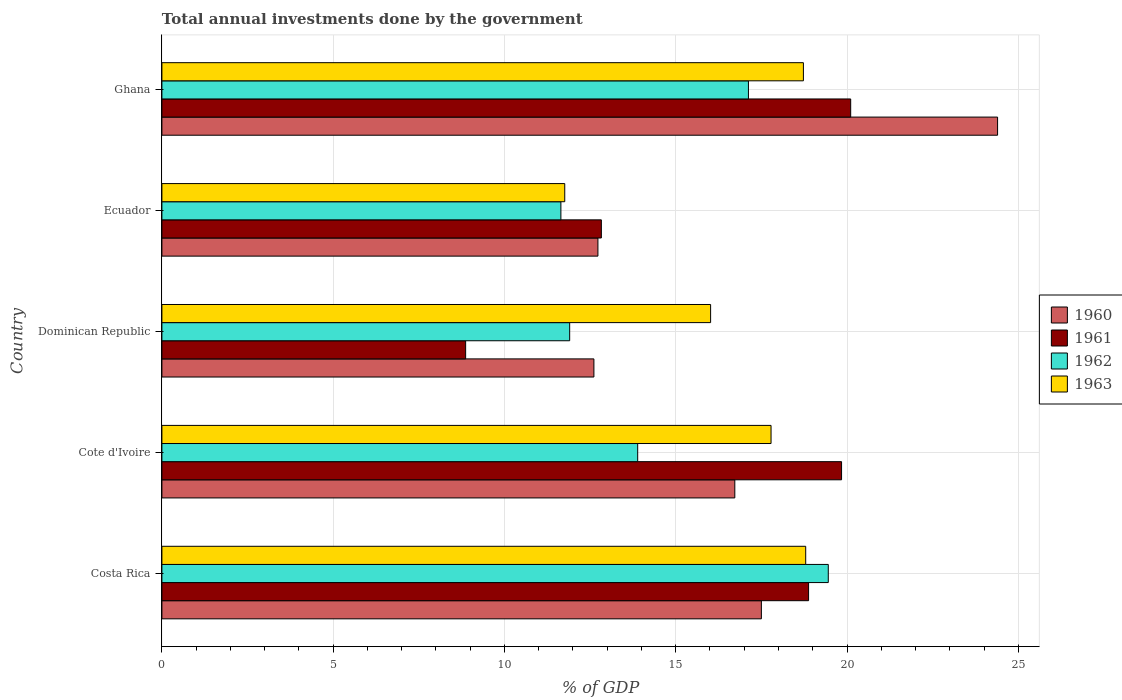How many different coloured bars are there?
Your answer should be compact. 4. How many groups of bars are there?
Your answer should be very brief. 5. Are the number of bars per tick equal to the number of legend labels?
Your answer should be compact. Yes. Are the number of bars on each tick of the Y-axis equal?
Provide a short and direct response. Yes. How many bars are there on the 4th tick from the top?
Ensure brevity in your answer.  4. What is the label of the 4th group of bars from the top?
Your answer should be compact. Cote d'Ivoire. What is the total annual investments done by the government in 1960 in Cote d'Ivoire?
Make the answer very short. 16.72. Across all countries, what is the maximum total annual investments done by the government in 1963?
Ensure brevity in your answer.  18.79. Across all countries, what is the minimum total annual investments done by the government in 1960?
Offer a very short reply. 12.61. In which country was the total annual investments done by the government in 1961 maximum?
Make the answer very short. Ghana. In which country was the total annual investments done by the government in 1963 minimum?
Offer a terse response. Ecuador. What is the total total annual investments done by the government in 1963 in the graph?
Ensure brevity in your answer.  83.08. What is the difference between the total annual investments done by the government in 1961 in Costa Rica and that in Dominican Republic?
Provide a short and direct response. 10.01. What is the difference between the total annual investments done by the government in 1960 in Cote d'Ivoire and the total annual investments done by the government in 1961 in Costa Rica?
Your response must be concise. -2.15. What is the average total annual investments done by the government in 1962 per country?
Ensure brevity in your answer.  14.8. What is the difference between the total annual investments done by the government in 1961 and total annual investments done by the government in 1962 in Ghana?
Your answer should be compact. 2.98. What is the ratio of the total annual investments done by the government in 1963 in Cote d'Ivoire to that in Dominican Republic?
Your response must be concise. 1.11. Is the total annual investments done by the government in 1963 in Costa Rica less than that in Ghana?
Your response must be concise. No. Is the difference between the total annual investments done by the government in 1961 in Costa Rica and Ghana greater than the difference between the total annual investments done by the government in 1962 in Costa Rica and Ghana?
Provide a succinct answer. No. What is the difference between the highest and the second highest total annual investments done by the government in 1961?
Your response must be concise. 0.27. What is the difference between the highest and the lowest total annual investments done by the government in 1960?
Your answer should be compact. 11.78. Is the sum of the total annual investments done by the government in 1963 in Cote d'Ivoire and Ecuador greater than the maximum total annual investments done by the government in 1961 across all countries?
Provide a short and direct response. Yes. Is it the case that in every country, the sum of the total annual investments done by the government in 1962 and total annual investments done by the government in 1960 is greater than the sum of total annual investments done by the government in 1961 and total annual investments done by the government in 1963?
Give a very brief answer. No. What does the 3rd bar from the bottom in Ecuador represents?
Offer a terse response. 1962. How many bars are there?
Provide a succinct answer. 20. Are all the bars in the graph horizontal?
Offer a very short reply. Yes. What is the difference between two consecutive major ticks on the X-axis?
Your answer should be compact. 5. Where does the legend appear in the graph?
Ensure brevity in your answer.  Center right. How many legend labels are there?
Your answer should be compact. 4. How are the legend labels stacked?
Offer a terse response. Vertical. What is the title of the graph?
Your response must be concise. Total annual investments done by the government. What is the label or title of the X-axis?
Make the answer very short. % of GDP. What is the label or title of the Y-axis?
Provide a short and direct response. Country. What is the % of GDP in 1960 in Costa Rica?
Your answer should be compact. 17.5. What is the % of GDP of 1961 in Costa Rica?
Give a very brief answer. 18.88. What is the % of GDP of 1962 in Costa Rica?
Keep it short and to the point. 19.45. What is the % of GDP of 1963 in Costa Rica?
Keep it short and to the point. 18.79. What is the % of GDP in 1960 in Cote d'Ivoire?
Give a very brief answer. 16.72. What is the % of GDP of 1961 in Cote d'Ivoire?
Ensure brevity in your answer.  19.84. What is the % of GDP in 1962 in Cote d'Ivoire?
Your response must be concise. 13.89. What is the % of GDP in 1963 in Cote d'Ivoire?
Your answer should be very brief. 17.78. What is the % of GDP of 1960 in Dominican Republic?
Your answer should be very brief. 12.61. What is the % of GDP of 1961 in Dominican Republic?
Make the answer very short. 8.87. What is the % of GDP in 1962 in Dominican Republic?
Offer a very short reply. 11.9. What is the % of GDP of 1963 in Dominican Republic?
Provide a succinct answer. 16.02. What is the % of GDP in 1960 in Ecuador?
Provide a succinct answer. 12.73. What is the % of GDP of 1961 in Ecuador?
Keep it short and to the point. 12.83. What is the % of GDP in 1962 in Ecuador?
Your response must be concise. 11.65. What is the % of GDP of 1963 in Ecuador?
Offer a terse response. 11.76. What is the % of GDP in 1960 in Ghana?
Offer a terse response. 24.4. What is the % of GDP in 1961 in Ghana?
Your answer should be very brief. 20.11. What is the % of GDP of 1962 in Ghana?
Offer a terse response. 17.12. What is the % of GDP of 1963 in Ghana?
Ensure brevity in your answer.  18.73. Across all countries, what is the maximum % of GDP in 1960?
Your response must be concise. 24.4. Across all countries, what is the maximum % of GDP of 1961?
Provide a short and direct response. 20.11. Across all countries, what is the maximum % of GDP in 1962?
Your answer should be compact. 19.45. Across all countries, what is the maximum % of GDP in 1963?
Ensure brevity in your answer.  18.79. Across all countries, what is the minimum % of GDP in 1960?
Provide a succinct answer. 12.61. Across all countries, what is the minimum % of GDP in 1961?
Keep it short and to the point. 8.87. Across all countries, what is the minimum % of GDP in 1962?
Make the answer very short. 11.65. Across all countries, what is the minimum % of GDP in 1963?
Give a very brief answer. 11.76. What is the total % of GDP of 1960 in the graph?
Make the answer very short. 83.96. What is the total % of GDP in 1961 in the graph?
Provide a short and direct response. 80.52. What is the total % of GDP of 1962 in the graph?
Your response must be concise. 74.02. What is the total % of GDP in 1963 in the graph?
Your answer should be compact. 83.08. What is the difference between the % of GDP in 1960 in Costa Rica and that in Cote d'Ivoire?
Ensure brevity in your answer.  0.78. What is the difference between the % of GDP in 1961 in Costa Rica and that in Cote d'Ivoire?
Your answer should be very brief. -0.96. What is the difference between the % of GDP in 1962 in Costa Rica and that in Cote d'Ivoire?
Make the answer very short. 5.56. What is the difference between the % of GDP in 1963 in Costa Rica and that in Cote d'Ivoire?
Offer a terse response. 1.01. What is the difference between the % of GDP in 1960 in Costa Rica and that in Dominican Republic?
Give a very brief answer. 4.89. What is the difference between the % of GDP of 1961 in Costa Rica and that in Dominican Republic?
Your answer should be compact. 10.01. What is the difference between the % of GDP in 1962 in Costa Rica and that in Dominican Republic?
Make the answer very short. 7.55. What is the difference between the % of GDP in 1963 in Costa Rica and that in Dominican Republic?
Make the answer very short. 2.78. What is the difference between the % of GDP of 1960 in Costa Rica and that in Ecuador?
Your response must be concise. 4.77. What is the difference between the % of GDP of 1961 in Costa Rica and that in Ecuador?
Your response must be concise. 6.05. What is the difference between the % of GDP of 1962 in Costa Rica and that in Ecuador?
Your answer should be compact. 7.81. What is the difference between the % of GDP of 1963 in Costa Rica and that in Ecuador?
Make the answer very short. 7.03. What is the difference between the % of GDP in 1960 in Costa Rica and that in Ghana?
Provide a short and direct response. -6.9. What is the difference between the % of GDP in 1961 in Costa Rica and that in Ghana?
Provide a short and direct response. -1.23. What is the difference between the % of GDP of 1962 in Costa Rica and that in Ghana?
Your answer should be compact. 2.33. What is the difference between the % of GDP in 1963 in Costa Rica and that in Ghana?
Make the answer very short. 0.07. What is the difference between the % of GDP in 1960 in Cote d'Ivoire and that in Dominican Republic?
Ensure brevity in your answer.  4.11. What is the difference between the % of GDP in 1961 in Cote d'Ivoire and that in Dominican Republic?
Give a very brief answer. 10.97. What is the difference between the % of GDP of 1962 in Cote d'Ivoire and that in Dominican Republic?
Make the answer very short. 1.99. What is the difference between the % of GDP in 1963 in Cote d'Ivoire and that in Dominican Republic?
Give a very brief answer. 1.76. What is the difference between the % of GDP in 1960 in Cote d'Ivoire and that in Ecuador?
Your answer should be compact. 4. What is the difference between the % of GDP in 1961 in Cote d'Ivoire and that in Ecuador?
Ensure brevity in your answer.  7.01. What is the difference between the % of GDP in 1962 in Cote d'Ivoire and that in Ecuador?
Offer a very short reply. 2.24. What is the difference between the % of GDP of 1963 in Cote d'Ivoire and that in Ecuador?
Keep it short and to the point. 6.02. What is the difference between the % of GDP in 1960 in Cote d'Ivoire and that in Ghana?
Your response must be concise. -7.67. What is the difference between the % of GDP of 1961 in Cote d'Ivoire and that in Ghana?
Ensure brevity in your answer.  -0.27. What is the difference between the % of GDP of 1962 in Cote d'Ivoire and that in Ghana?
Ensure brevity in your answer.  -3.23. What is the difference between the % of GDP in 1963 in Cote d'Ivoire and that in Ghana?
Your response must be concise. -0.94. What is the difference between the % of GDP in 1960 in Dominican Republic and that in Ecuador?
Your answer should be compact. -0.12. What is the difference between the % of GDP of 1961 in Dominican Republic and that in Ecuador?
Give a very brief answer. -3.96. What is the difference between the % of GDP of 1962 in Dominican Republic and that in Ecuador?
Your answer should be very brief. 0.26. What is the difference between the % of GDP of 1963 in Dominican Republic and that in Ecuador?
Offer a very short reply. 4.26. What is the difference between the % of GDP of 1960 in Dominican Republic and that in Ghana?
Offer a terse response. -11.78. What is the difference between the % of GDP in 1961 in Dominican Republic and that in Ghana?
Ensure brevity in your answer.  -11.24. What is the difference between the % of GDP of 1962 in Dominican Republic and that in Ghana?
Keep it short and to the point. -5.22. What is the difference between the % of GDP in 1963 in Dominican Republic and that in Ghana?
Offer a terse response. -2.71. What is the difference between the % of GDP in 1960 in Ecuador and that in Ghana?
Ensure brevity in your answer.  -11.67. What is the difference between the % of GDP of 1961 in Ecuador and that in Ghana?
Your answer should be compact. -7.28. What is the difference between the % of GDP of 1962 in Ecuador and that in Ghana?
Provide a short and direct response. -5.48. What is the difference between the % of GDP of 1963 in Ecuador and that in Ghana?
Make the answer very short. -6.97. What is the difference between the % of GDP in 1960 in Costa Rica and the % of GDP in 1961 in Cote d'Ivoire?
Give a very brief answer. -2.34. What is the difference between the % of GDP of 1960 in Costa Rica and the % of GDP of 1962 in Cote d'Ivoire?
Offer a very short reply. 3.61. What is the difference between the % of GDP in 1960 in Costa Rica and the % of GDP in 1963 in Cote d'Ivoire?
Make the answer very short. -0.28. What is the difference between the % of GDP of 1961 in Costa Rica and the % of GDP of 1962 in Cote d'Ivoire?
Provide a short and direct response. 4.99. What is the difference between the % of GDP in 1961 in Costa Rica and the % of GDP in 1963 in Cote d'Ivoire?
Provide a succinct answer. 1.1. What is the difference between the % of GDP of 1962 in Costa Rica and the % of GDP of 1963 in Cote d'Ivoire?
Your response must be concise. 1.67. What is the difference between the % of GDP in 1960 in Costa Rica and the % of GDP in 1961 in Dominican Republic?
Provide a succinct answer. 8.63. What is the difference between the % of GDP of 1960 in Costa Rica and the % of GDP of 1962 in Dominican Republic?
Your response must be concise. 5.6. What is the difference between the % of GDP in 1960 in Costa Rica and the % of GDP in 1963 in Dominican Republic?
Your answer should be very brief. 1.48. What is the difference between the % of GDP of 1961 in Costa Rica and the % of GDP of 1962 in Dominican Republic?
Your answer should be compact. 6.97. What is the difference between the % of GDP in 1961 in Costa Rica and the % of GDP in 1963 in Dominican Republic?
Provide a succinct answer. 2.86. What is the difference between the % of GDP of 1962 in Costa Rica and the % of GDP of 1963 in Dominican Republic?
Your answer should be compact. 3.44. What is the difference between the % of GDP of 1960 in Costa Rica and the % of GDP of 1961 in Ecuador?
Offer a very short reply. 4.67. What is the difference between the % of GDP of 1960 in Costa Rica and the % of GDP of 1962 in Ecuador?
Your response must be concise. 5.85. What is the difference between the % of GDP of 1960 in Costa Rica and the % of GDP of 1963 in Ecuador?
Give a very brief answer. 5.74. What is the difference between the % of GDP of 1961 in Costa Rica and the % of GDP of 1962 in Ecuador?
Make the answer very short. 7.23. What is the difference between the % of GDP in 1961 in Costa Rica and the % of GDP in 1963 in Ecuador?
Give a very brief answer. 7.12. What is the difference between the % of GDP of 1962 in Costa Rica and the % of GDP of 1963 in Ecuador?
Your answer should be very brief. 7.69. What is the difference between the % of GDP in 1960 in Costa Rica and the % of GDP in 1961 in Ghana?
Make the answer very short. -2.61. What is the difference between the % of GDP of 1960 in Costa Rica and the % of GDP of 1962 in Ghana?
Offer a terse response. 0.38. What is the difference between the % of GDP in 1960 in Costa Rica and the % of GDP in 1963 in Ghana?
Make the answer very short. -1.23. What is the difference between the % of GDP in 1961 in Costa Rica and the % of GDP in 1962 in Ghana?
Offer a very short reply. 1.76. What is the difference between the % of GDP in 1961 in Costa Rica and the % of GDP in 1963 in Ghana?
Offer a very short reply. 0.15. What is the difference between the % of GDP in 1962 in Costa Rica and the % of GDP in 1963 in Ghana?
Provide a short and direct response. 0.73. What is the difference between the % of GDP in 1960 in Cote d'Ivoire and the % of GDP in 1961 in Dominican Republic?
Your answer should be very brief. 7.86. What is the difference between the % of GDP in 1960 in Cote d'Ivoire and the % of GDP in 1962 in Dominican Republic?
Provide a succinct answer. 4.82. What is the difference between the % of GDP of 1960 in Cote d'Ivoire and the % of GDP of 1963 in Dominican Republic?
Offer a very short reply. 0.71. What is the difference between the % of GDP of 1961 in Cote d'Ivoire and the % of GDP of 1962 in Dominican Republic?
Offer a very short reply. 7.94. What is the difference between the % of GDP in 1961 in Cote d'Ivoire and the % of GDP in 1963 in Dominican Republic?
Offer a very short reply. 3.82. What is the difference between the % of GDP of 1962 in Cote d'Ivoire and the % of GDP of 1963 in Dominican Republic?
Provide a short and direct response. -2.13. What is the difference between the % of GDP in 1960 in Cote d'Ivoire and the % of GDP in 1961 in Ecuador?
Offer a terse response. 3.9. What is the difference between the % of GDP in 1960 in Cote d'Ivoire and the % of GDP in 1962 in Ecuador?
Offer a very short reply. 5.08. What is the difference between the % of GDP of 1960 in Cote d'Ivoire and the % of GDP of 1963 in Ecuador?
Offer a terse response. 4.96. What is the difference between the % of GDP of 1961 in Cote d'Ivoire and the % of GDP of 1962 in Ecuador?
Make the answer very short. 8.19. What is the difference between the % of GDP of 1961 in Cote d'Ivoire and the % of GDP of 1963 in Ecuador?
Ensure brevity in your answer.  8.08. What is the difference between the % of GDP of 1962 in Cote d'Ivoire and the % of GDP of 1963 in Ecuador?
Give a very brief answer. 2.13. What is the difference between the % of GDP of 1960 in Cote d'Ivoire and the % of GDP of 1961 in Ghana?
Your answer should be compact. -3.38. What is the difference between the % of GDP in 1960 in Cote d'Ivoire and the % of GDP in 1962 in Ghana?
Make the answer very short. -0.4. What is the difference between the % of GDP in 1960 in Cote d'Ivoire and the % of GDP in 1963 in Ghana?
Your answer should be compact. -2. What is the difference between the % of GDP of 1961 in Cote d'Ivoire and the % of GDP of 1962 in Ghana?
Make the answer very short. 2.72. What is the difference between the % of GDP in 1961 in Cote d'Ivoire and the % of GDP in 1963 in Ghana?
Your answer should be very brief. 1.11. What is the difference between the % of GDP in 1962 in Cote d'Ivoire and the % of GDP in 1963 in Ghana?
Your answer should be compact. -4.84. What is the difference between the % of GDP of 1960 in Dominican Republic and the % of GDP of 1961 in Ecuador?
Your response must be concise. -0.22. What is the difference between the % of GDP in 1960 in Dominican Republic and the % of GDP in 1962 in Ecuador?
Your answer should be compact. 0.96. What is the difference between the % of GDP of 1960 in Dominican Republic and the % of GDP of 1963 in Ecuador?
Give a very brief answer. 0.85. What is the difference between the % of GDP in 1961 in Dominican Republic and the % of GDP in 1962 in Ecuador?
Your response must be concise. -2.78. What is the difference between the % of GDP in 1961 in Dominican Republic and the % of GDP in 1963 in Ecuador?
Your answer should be very brief. -2.89. What is the difference between the % of GDP in 1962 in Dominican Republic and the % of GDP in 1963 in Ecuador?
Your answer should be very brief. 0.14. What is the difference between the % of GDP in 1960 in Dominican Republic and the % of GDP in 1961 in Ghana?
Provide a succinct answer. -7.5. What is the difference between the % of GDP of 1960 in Dominican Republic and the % of GDP of 1962 in Ghana?
Offer a very short reply. -4.51. What is the difference between the % of GDP in 1960 in Dominican Republic and the % of GDP in 1963 in Ghana?
Keep it short and to the point. -6.12. What is the difference between the % of GDP of 1961 in Dominican Republic and the % of GDP of 1962 in Ghana?
Your answer should be very brief. -8.26. What is the difference between the % of GDP in 1961 in Dominican Republic and the % of GDP in 1963 in Ghana?
Provide a succinct answer. -9.86. What is the difference between the % of GDP of 1962 in Dominican Republic and the % of GDP of 1963 in Ghana?
Ensure brevity in your answer.  -6.82. What is the difference between the % of GDP of 1960 in Ecuador and the % of GDP of 1961 in Ghana?
Offer a terse response. -7.38. What is the difference between the % of GDP of 1960 in Ecuador and the % of GDP of 1962 in Ghana?
Offer a very short reply. -4.39. What is the difference between the % of GDP in 1960 in Ecuador and the % of GDP in 1963 in Ghana?
Give a very brief answer. -6. What is the difference between the % of GDP of 1961 in Ecuador and the % of GDP of 1962 in Ghana?
Your answer should be compact. -4.29. What is the difference between the % of GDP in 1961 in Ecuador and the % of GDP in 1963 in Ghana?
Keep it short and to the point. -5.9. What is the difference between the % of GDP in 1962 in Ecuador and the % of GDP in 1963 in Ghana?
Give a very brief answer. -7.08. What is the average % of GDP of 1960 per country?
Give a very brief answer. 16.79. What is the average % of GDP in 1961 per country?
Your response must be concise. 16.1. What is the average % of GDP of 1962 per country?
Offer a terse response. 14.8. What is the average % of GDP of 1963 per country?
Give a very brief answer. 16.62. What is the difference between the % of GDP in 1960 and % of GDP in 1961 in Costa Rica?
Offer a terse response. -1.38. What is the difference between the % of GDP in 1960 and % of GDP in 1962 in Costa Rica?
Ensure brevity in your answer.  -1.95. What is the difference between the % of GDP in 1960 and % of GDP in 1963 in Costa Rica?
Offer a terse response. -1.29. What is the difference between the % of GDP of 1961 and % of GDP of 1962 in Costa Rica?
Make the answer very short. -0.58. What is the difference between the % of GDP in 1961 and % of GDP in 1963 in Costa Rica?
Offer a terse response. 0.08. What is the difference between the % of GDP of 1962 and % of GDP of 1963 in Costa Rica?
Provide a succinct answer. 0.66. What is the difference between the % of GDP of 1960 and % of GDP of 1961 in Cote d'Ivoire?
Provide a short and direct response. -3.12. What is the difference between the % of GDP in 1960 and % of GDP in 1962 in Cote d'Ivoire?
Your answer should be compact. 2.84. What is the difference between the % of GDP in 1960 and % of GDP in 1963 in Cote d'Ivoire?
Keep it short and to the point. -1.06. What is the difference between the % of GDP of 1961 and % of GDP of 1962 in Cote d'Ivoire?
Give a very brief answer. 5.95. What is the difference between the % of GDP of 1961 and % of GDP of 1963 in Cote d'Ivoire?
Your response must be concise. 2.06. What is the difference between the % of GDP of 1962 and % of GDP of 1963 in Cote d'Ivoire?
Give a very brief answer. -3.89. What is the difference between the % of GDP of 1960 and % of GDP of 1961 in Dominican Republic?
Keep it short and to the point. 3.74. What is the difference between the % of GDP of 1960 and % of GDP of 1962 in Dominican Republic?
Your answer should be very brief. 0.71. What is the difference between the % of GDP in 1960 and % of GDP in 1963 in Dominican Republic?
Ensure brevity in your answer.  -3.41. What is the difference between the % of GDP of 1961 and % of GDP of 1962 in Dominican Republic?
Ensure brevity in your answer.  -3.04. What is the difference between the % of GDP in 1961 and % of GDP in 1963 in Dominican Republic?
Provide a short and direct response. -7.15. What is the difference between the % of GDP in 1962 and % of GDP in 1963 in Dominican Republic?
Offer a very short reply. -4.11. What is the difference between the % of GDP of 1960 and % of GDP of 1961 in Ecuador?
Provide a short and direct response. -0.1. What is the difference between the % of GDP in 1960 and % of GDP in 1962 in Ecuador?
Give a very brief answer. 1.08. What is the difference between the % of GDP in 1961 and % of GDP in 1962 in Ecuador?
Give a very brief answer. 1.18. What is the difference between the % of GDP of 1961 and % of GDP of 1963 in Ecuador?
Your response must be concise. 1.07. What is the difference between the % of GDP in 1962 and % of GDP in 1963 in Ecuador?
Provide a succinct answer. -0.11. What is the difference between the % of GDP of 1960 and % of GDP of 1961 in Ghana?
Provide a succinct answer. 4.29. What is the difference between the % of GDP of 1960 and % of GDP of 1962 in Ghana?
Your answer should be very brief. 7.27. What is the difference between the % of GDP of 1960 and % of GDP of 1963 in Ghana?
Your answer should be compact. 5.67. What is the difference between the % of GDP of 1961 and % of GDP of 1962 in Ghana?
Offer a terse response. 2.98. What is the difference between the % of GDP of 1961 and % of GDP of 1963 in Ghana?
Offer a very short reply. 1.38. What is the difference between the % of GDP in 1962 and % of GDP in 1963 in Ghana?
Keep it short and to the point. -1.6. What is the ratio of the % of GDP in 1960 in Costa Rica to that in Cote d'Ivoire?
Your answer should be compact. 1.05. What is the ratio of the % of GDP of 1961 in Costa Rica to that in Cote d'Ivoire?
Offer a very short reply. 0.95. What is the ratio of the % of GDP in 1962 in Costa Rica to that in Cote d'Ivoire?
Give a very brief answer. 1.4. What is the ratio of the % of GDP in 1963 in Costa Rica to that in Cote d'Ivoire?
Your answer should be very brief. 1.06. What is the ratio of the % of GDP of 1960 in Costa Rica to that in Dominican Republic?
Make the answer very short. 1.39. What is the ratio of the % of GDP in 1961 in Costa Rica to that in Dominican Republic?
Provide a succinct answer. 2.13. What is the ratio of the % of GDP of 1962 in Costa Rica to that in Dominican Republic?
Ensure brevity in your answer.  1.63. What is the ratio of the % of GDP in 1963 in Costa Rica to that in Dominican Republic?
Ensure brevity in your answer.  1.17. What is the ratio of the % of GDP in 1960 in Costa Rica to that in Ecuador?
Your answer should be very brief. 1.37. What is the ratio of the % of GDP of 1961 in Costa Rica to that in Ecuador?
Offer a very short reply. 1.47. What is the ratio of the % of GDP in 1962 in Costa Rica to that in Ecuador?
Your answer should be compact. 1.67. What is the ratio of the % of GDP of 1963 in Costa Rica to that in Ecuador?
Offer a very short reply. 1.6. What is the ratio of the % of GDP of 1960 in Costa Rica to that in Ghana?
Offer a terse response. 0.72. What is the ratio of the % of GDP of 1961 in Costa Rica to that in Ghana?
Keep it short and to the point. 0.94. What is the ratio of the % of GDP of 1962 in Costa Rica to that in Ghana?
Your response must be concise. 1.14. What is the ratio of the % of GDP of 1960 in Cote d'Ivoire to that in Dominican Republic?
Provide a short and direct response. 1.33. What is the ratio of the % of GDP of 1961 in Cote d'Ivoire to that in Dominican Republic?
Your answer should be compact. 2.24. What is the ratio of the % of GDP of 1962 in Cote d'Ivoire to that in Dominican Republic?
Make the answer very short. 1.17. What is the ratio of the % of GDP in 1963 in Cote d'Ivoire to that in Dominican Republic?
Give a very brief answer. 1.11. What is the ratio of the % of GDP in 1960 in Cote d'Ivoire to that in Ecuador?
Offer a terse response. 1.31. What is the ratio of the % of GDP in 1961 in Cote d'Ivoire to that in Ecuador?
Your response must be concise. 1.55. What is the ratio of the % of GDP of 1962 in Cote d'Ivoire to that in Ecuador?
Your answer should be very brief. 1.19. What is the ratio of the % of GDP of 1963 in Cote d'Ivoire to that in Ecuador?
Provide a short and direct response. 1.51. What is the ratio of the % of GDP of 1960 in Cote d'Ivoire to that in Ghana?
Offer a very short reply. 0.69. What is the ratio of the % of GDP of 1961 in Cote d'Ivoire to that in Ghana?
Offer a terse response. 0.99. What is the ratio of the % of GDP of 1962 in Cote d'Ivoire to that in Ghana?
Your response must be concise. 0.81. What is the ratio of the % of GDP of 1963 in Cote d'Ivoire to that in Ghana?
Provide a short and direct response. 0.95. What is the ratio of the % of GDP of 1961 in Dominican Republic to that in Ecuador?
Keep it short and to the point. 0.69. What is the ratio of the % of GDP in 1962 in Dominican Republic to that in Ecuador?
Provide a succinct answer. 1.02. What is the ratio of the % of GDP in 1963 in Dominican Republic to that in Ecuador?
Ensure brevity in your answer.  1.36. What is the ratio of the % of GDP in 1960 in Dominican Republic to that in Ghana?
Your answer should be compact. 0.52. What is the ratio of the % of GDP in 1961 in Dominican Republic to that in Ghana?
Ensure brevity in your answer.  0.44. What is the ratio of the % of GDP of 1962 in Dominican Republic to that in Ghana?
Provide a short and direct response. 0.7. What is the ratio of the % of GDP in 1963 in Dominican Republic to that in Ghana?
Offer a very short reply. 0.86. What is the ratio of the % of GDP of 1960 in Ecuador to that in Ghana?
Keep it short and to the point. 0.52. What is the ratio of the % of GDP of 1961 in Ecuador to that in Ghana?
Give a very brief answer. 0.64. What is the ratio of the % of GDP of 1962 in Ecuador to that in Ghana?
Ensure brevity in your answer.  0.68. What is the ratio of the % of GDP of 1963 in Ecuador to that in Ghana?
Your answer should be very brief. 0.63. What is the difference between the highest and the second highest % of GDP of 1960?
Provide a succinct answer. 6.9. What is the difference between the highest and the second highest % of GDP of 1961?
Your answer should be compact. 0.27. What is the difference between the highest and the second highest % of GDP in 1962?
Your response must be concise. 2.33. What is the difference between the highest and the second highest % of GDP of 1963?
Offer a terse response. 0.07. What is the difference between the highest and the lowest % of GDP of 1960?
Your answer should be compact. 11.78. What is the difference between the highest and the lowest % of GDP of 1961?
Provide a succinct answer. 11.24. What is the difference between the highest and the lowest % of GDP in 1962?
Provide a succinct answer. 7.81. What is the difference between the highest and the lowest % of GDP of 1963?
Your answer should be compact. 7.03. 